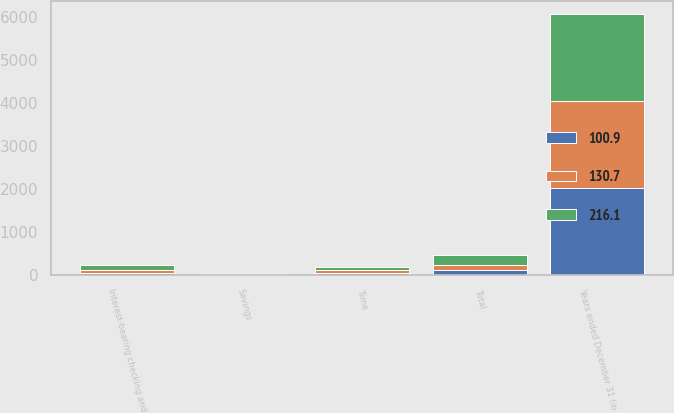Convert chart to OTSL. <chart><loc_0><loc_0><loc_500><loc_500><stacked_bar_chart><ecel><fcel>Years ended December 31 (in<fcel>Savings<fcel>Interest-bearing checking and<fcel>Time<fcel>Total<nl><fcel>216.1<fcel>2018<fcel>7.2<fcel>120.2<fcel>88.7<fcel>216.1<nl><fcel>130.7<fcel>2017<fcel>9.7<fcel>70.4<fcel>50.6<fcel>130.7<nl><fcel>100.9<fcel>2016<fcel>9.6<fcel>43.4<fcel>47.9<fcel>100.9<nl></chart> 